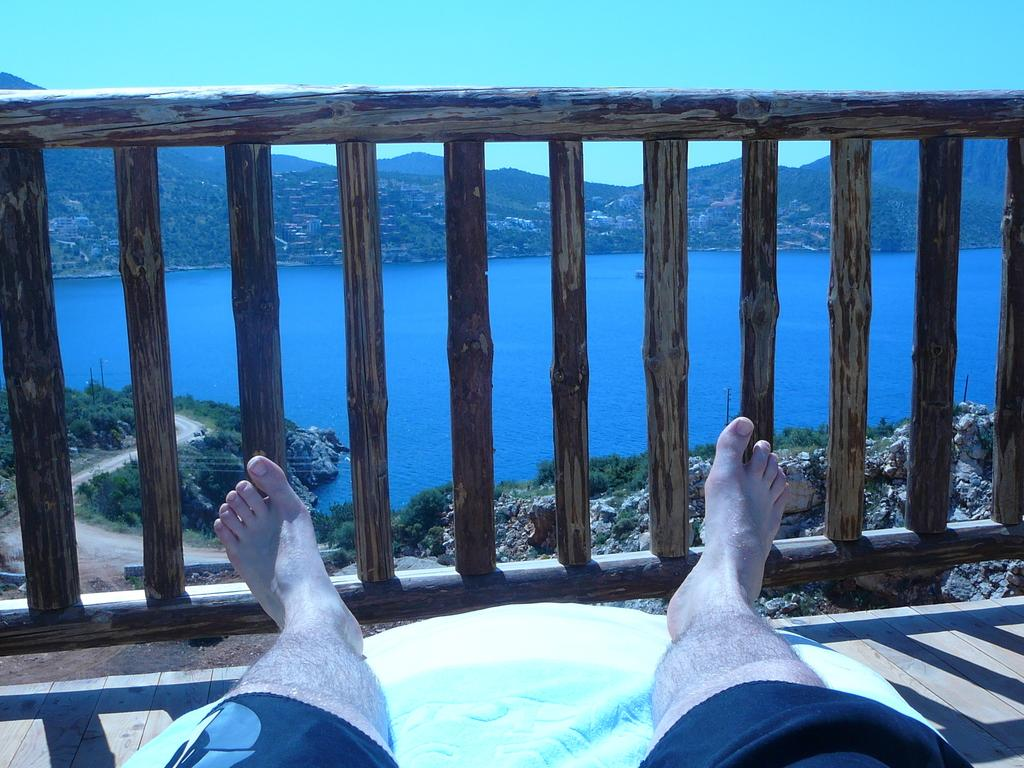What part of a person can be seen in the image? There are legs visible in the image. What type of fencing is present in the image? There is wooden fencing in the image. What natural features are depicted in the image? There are hills beside a lake in the image. What is visible at the top of the image? The sky is visible at the top of the image. How far is the end of the voyage from the starting point in the image? There is no voyage depicted in the image, so it is not possible to determine the distance or end point. 